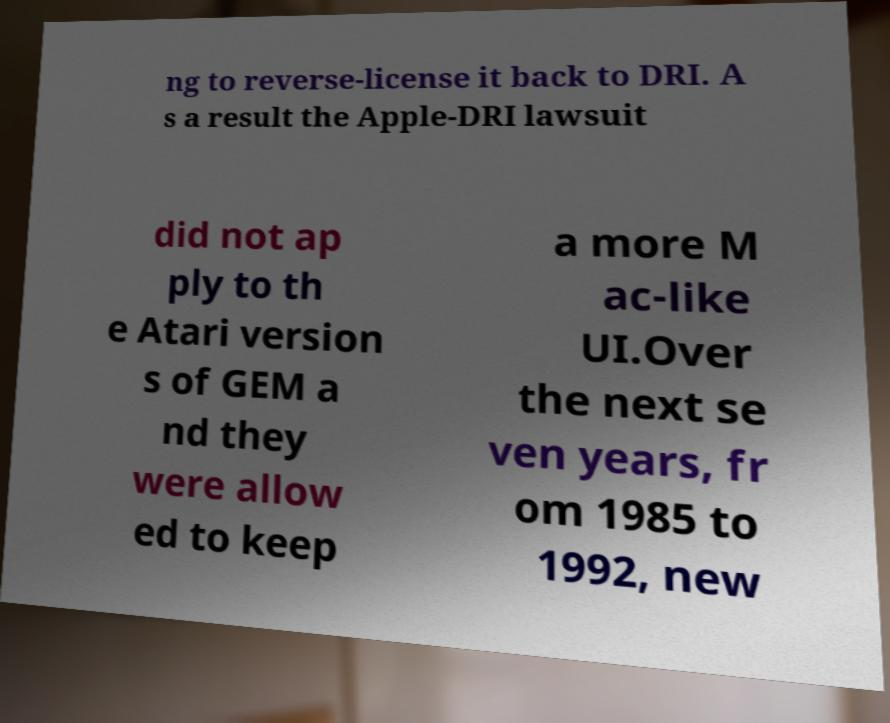Can you read and provide the text displayed in the image?This photo seems to have some interesting text. Can you extract and type it out for me? ng to reverse-license it back to DRI. A s a result the Apple-DRI lawsuit did not ap ply to th e Atari version s of GEM a nd they were allow ed to keep a more M ac-like UI.Over the next se ven years, fr om 1985 to 1992, new 